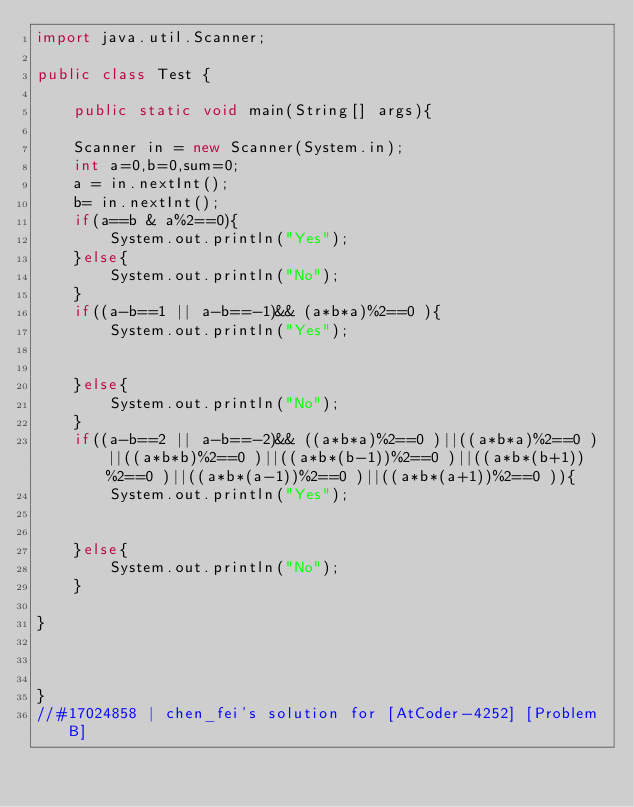<code> <loc_0><loc_0><loc_500><loc_500><_Java_>import java.util.Scanner;

public class Test {
	
	public static void main(String[] args){
	
	Scanner in = new Scanner(System.in);
	int a=0,b=0,sum=0;	
	a = in.nextInt();	
	b= in.nextInt();
	if(a==b & a%2==0){
		System.out.println("Yes");
	}else{
		System.out.println("No");
	}
	if((a-b==1 || a-b==-1)&& (a*b*a)%2==0 ){
		System.out.println("Yes");
		
		
	}else{
		System.out.println("No");
	}
	if((a-b==2 || a-b==-2)&& ((a*b*a)%2==0 )||((a*b*a)%2==0 )||((a*b*b)%2==0 )||((a*b*(b-1))%2==0 )||((a*b*(b+1))%2==0 )||((a*b*(a-1))%2==0 )||((a*b*(a+1))%2==0 )){
		System.out.println("Yes");
		
		
	}else{
		System.out.println("No");
	}
	
}


	
}
//#17024858 | chen_fei's solution for [AtCoder-4252] [Problem B]</code> 